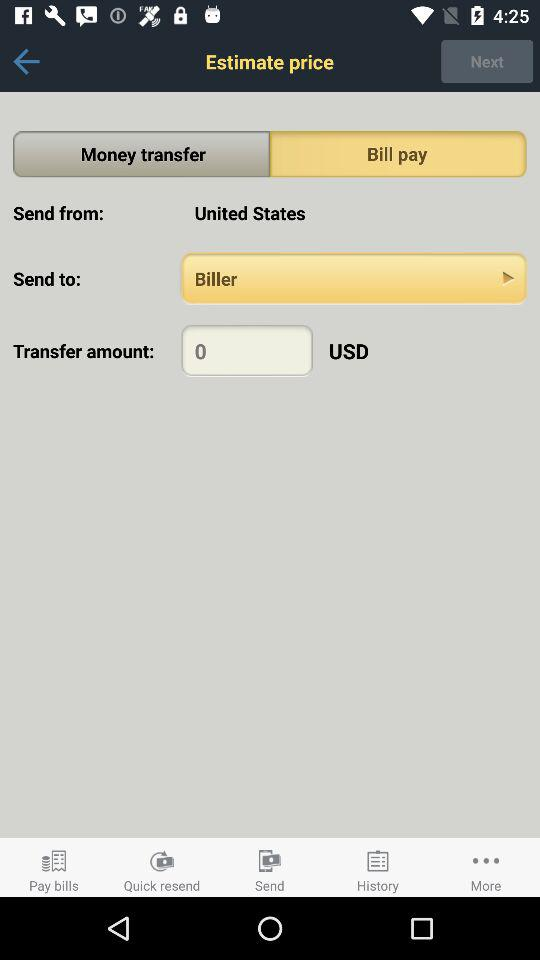What country is the transfer from? The transfer is from the United States. 